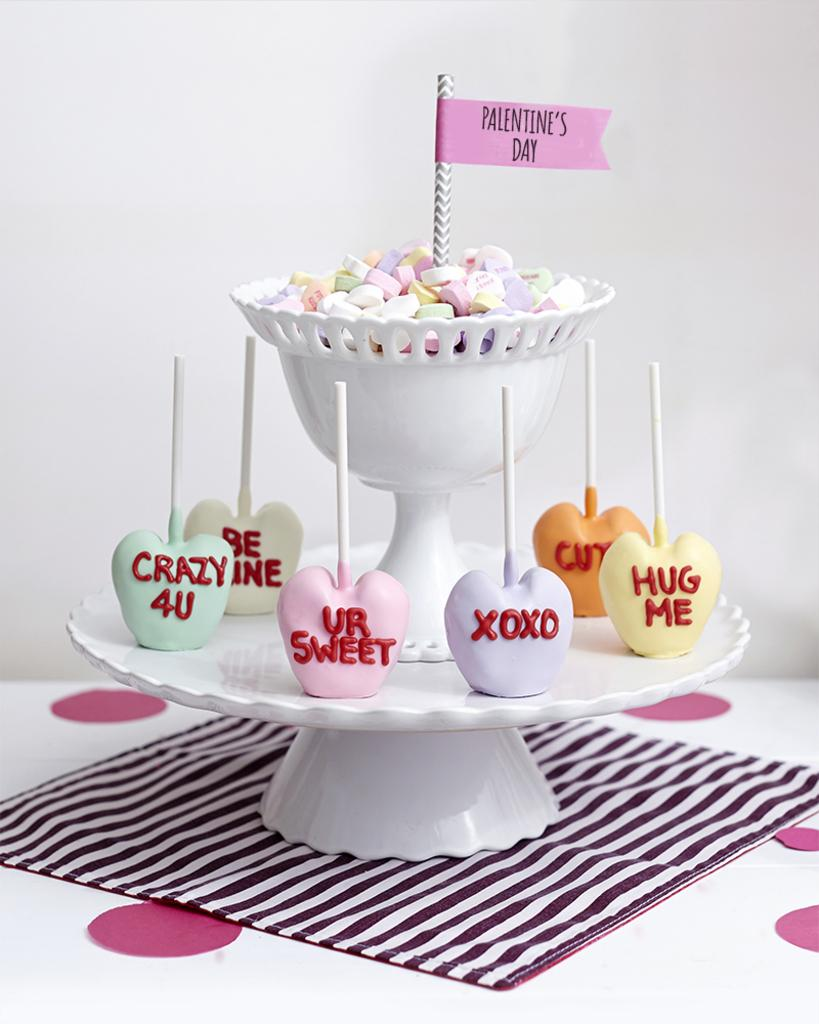What is the main object in the image? There is a cupcake holder in the image. What is the cupcake holder made of? The cupcake holder consists of candies. What is the cupcake holder placed on? The cupcake holder is placed on a cloth. What can be seen in the background of the image? There is a white surface visible in the background of the image. Who is the creator of the cupcake holder in the image? The image does not provide information about the creator of the cupcake holder. 